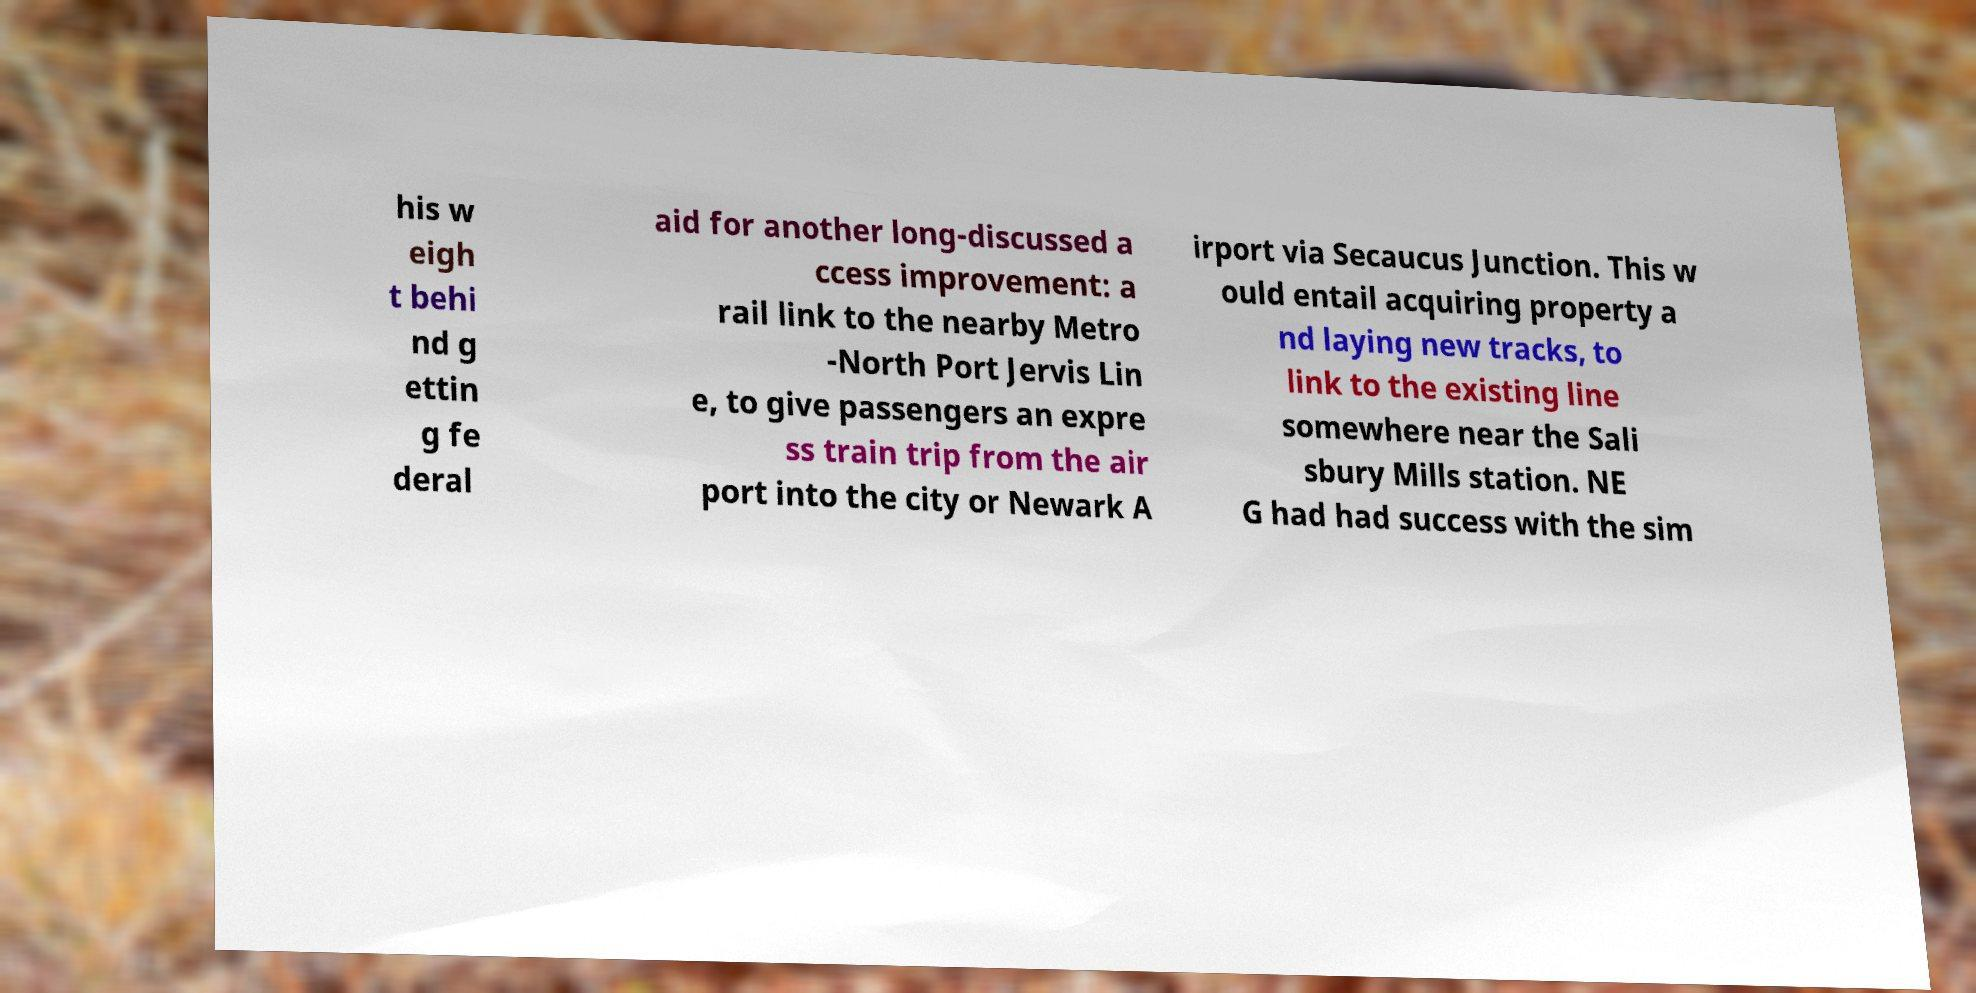There's text embedded in this image that I need extracted. Can you transcribe it verbatim? his w eigh t behi nd g ettin g fe deral aid for another long-discussed a ccess improvement: a rail link to the nearby Metro -North Port Jervis Lin e, to give passengers an expre ss train trip from the air port into the city or Newark A irport via Secaucus Junction. This w ould entail acquiring property a nd laying new tracks, to link to the existing line somewhere near the Sali sbury Mills station. NE G had had success with the sim 